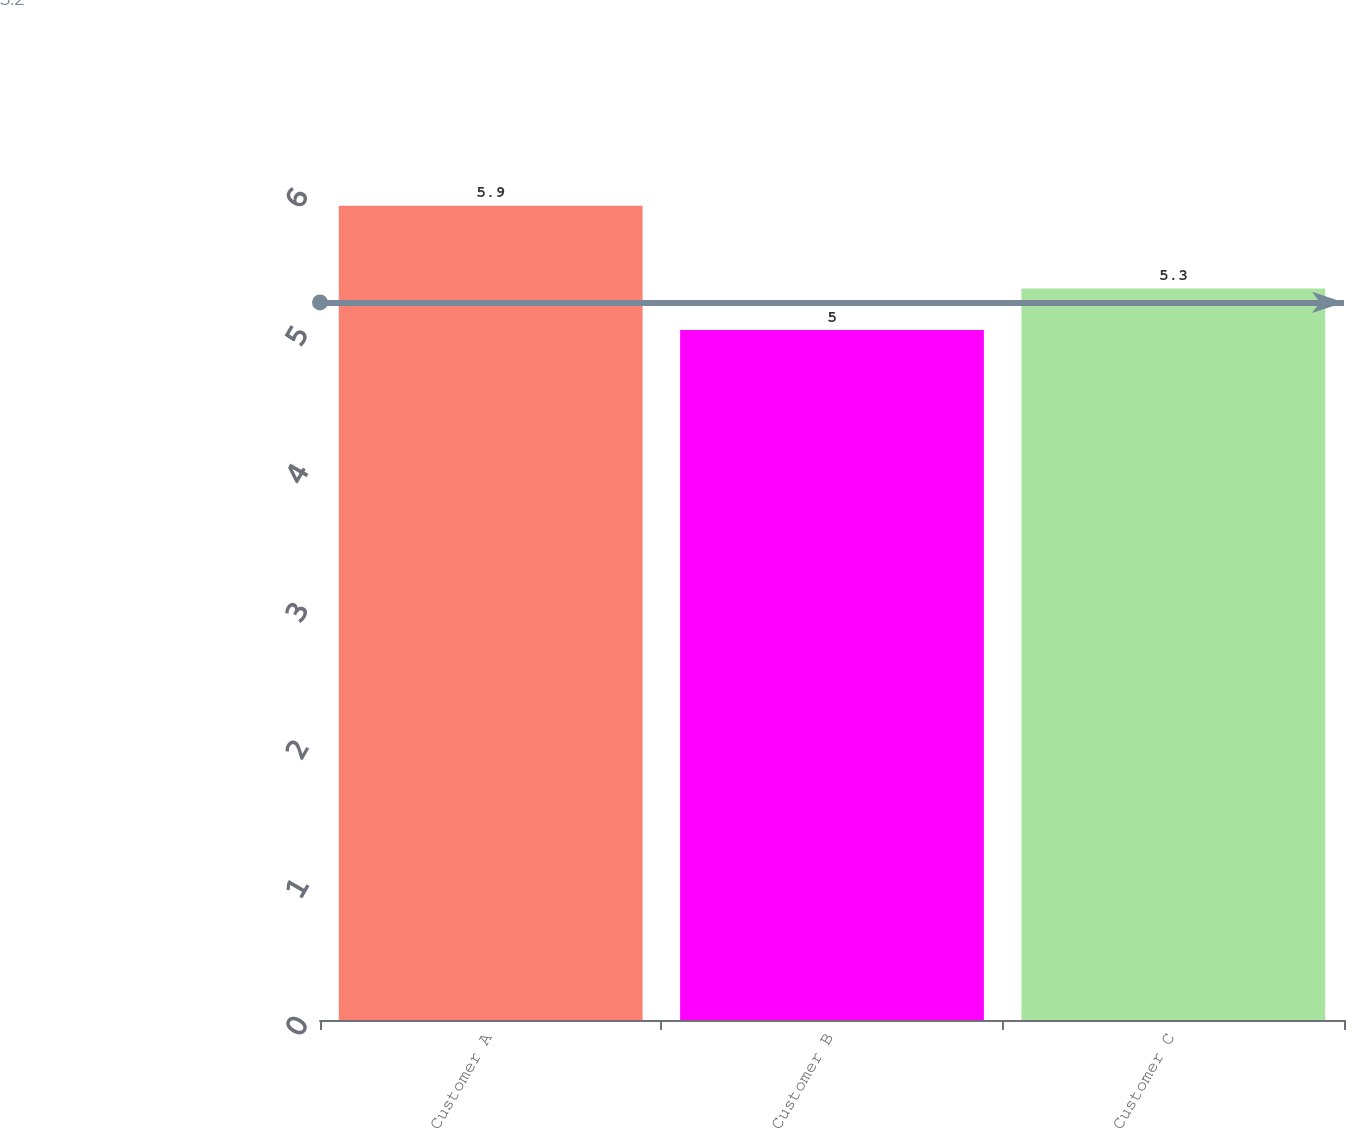Convert chart to OTSL. <chart><loc_0><loc_0><loc_500><loc_500><bar_chart><fcel>Customer A<fcel>Customer B<fcel>Customer C<nl><fcel>5.9<fcel>5<fcel>5.3<nl></chart> 